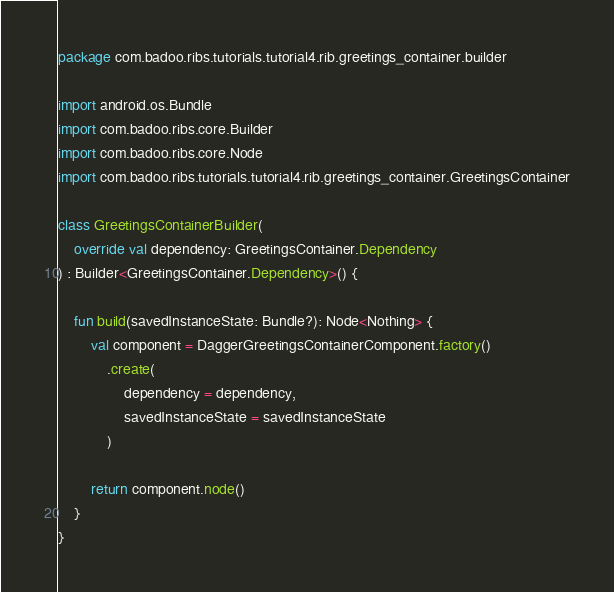Convert code to text. <code><loc_0><loc_0><loc_500><loc_500><_Kotlin_>package com.badoo.ribs.tutorials.tutorial4.rib.greetings_container.builder

import android.os.Bundle
import com.badoo.ribs.core.Builder
import com.badoo.ribs.core.Node
import com.badoo.ribs.tutorials.tutorial4.rib.greetings_container.GreetingsContainer

class GreetingsContainerBuilder(
    override val dependency: GreetingsContainer.Dependency
) : Builder<GreetingsContainer.Dependency>() {

    fun build(savedInstanceState: Bundle?): Node<Nothing> {
        val component = DaggerGreetingsContainerComponent.factory()
            .create(
                dependency = dependency,
                savedInstanceState = savedInstanceState
            )

        return component.node()
    }
}
</code> 